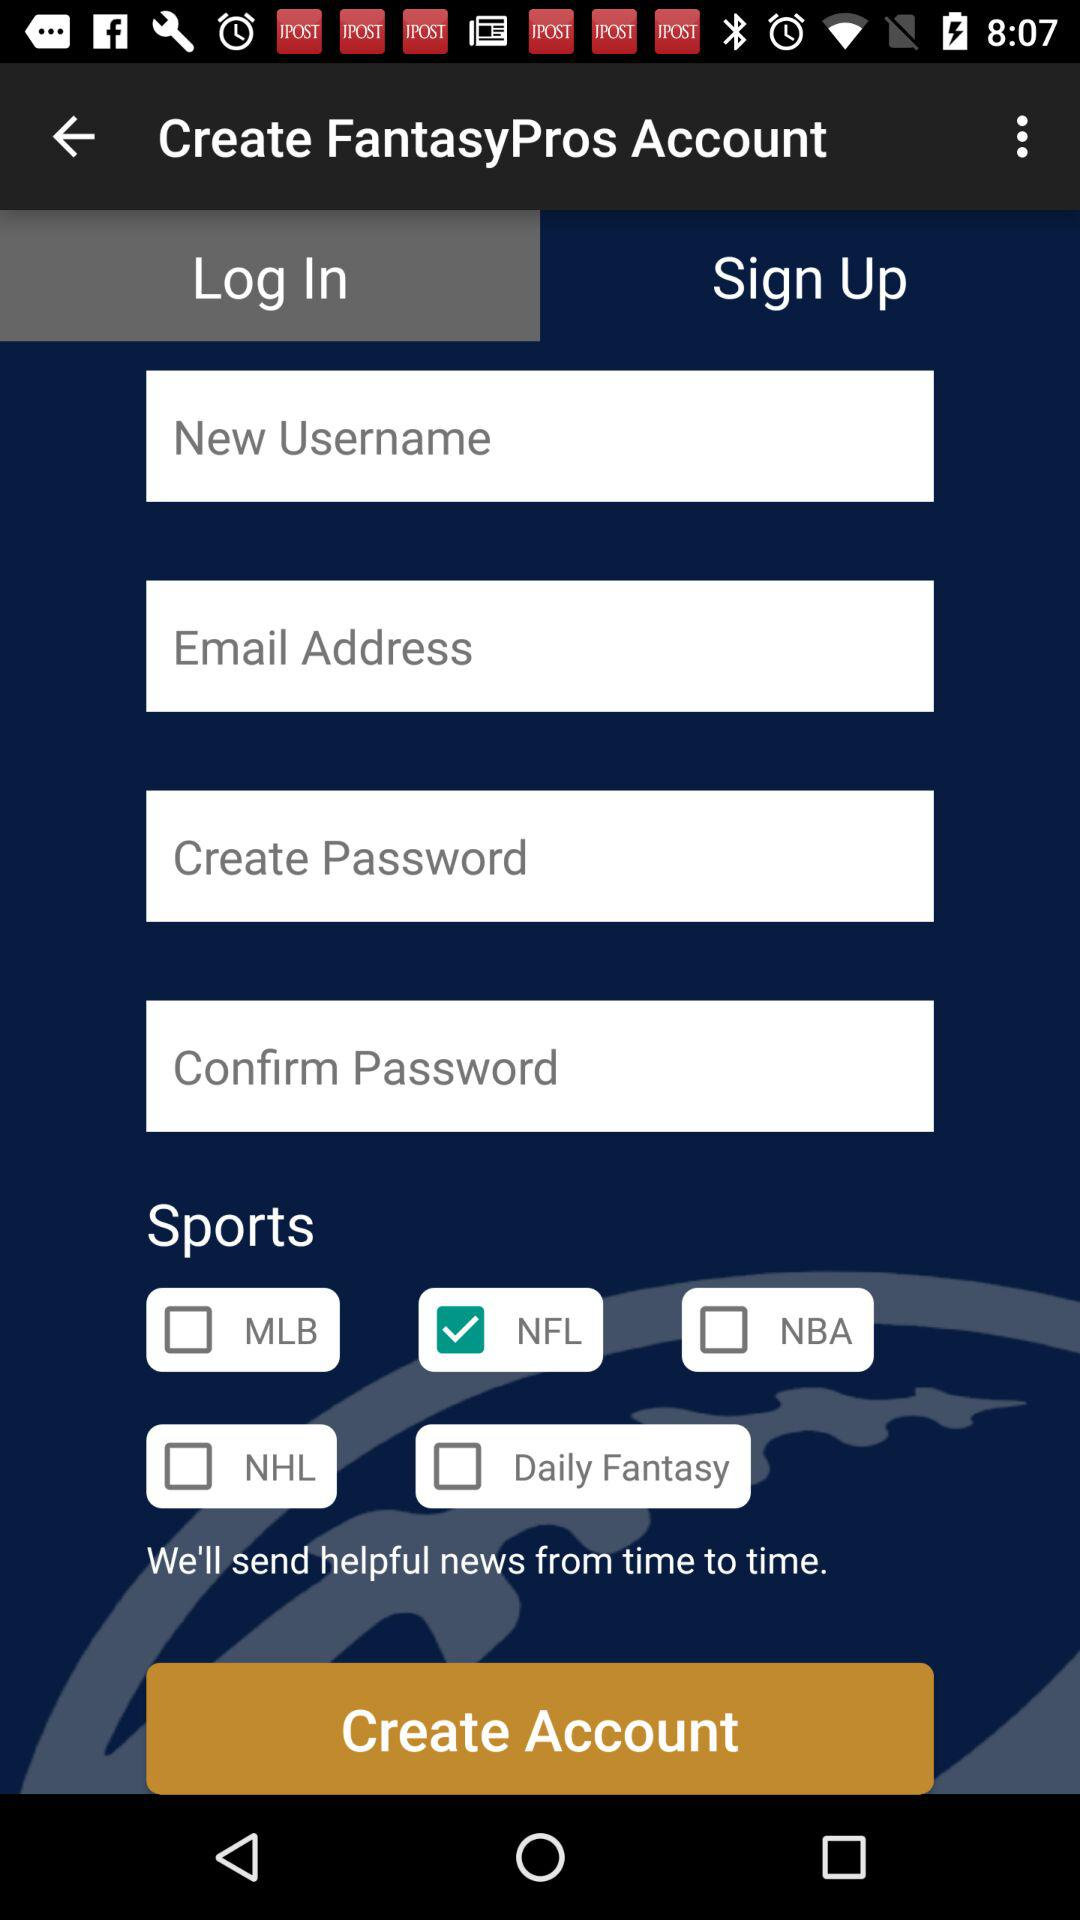How many sports are available to select?
Answer the question using a single word or phrase. 5 